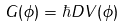Convert formula to latex. <formula><loc_0><loc_0><loc_500><loc_500>G ( \phi ) = \hbar { D } V ( \phi )</formula> 